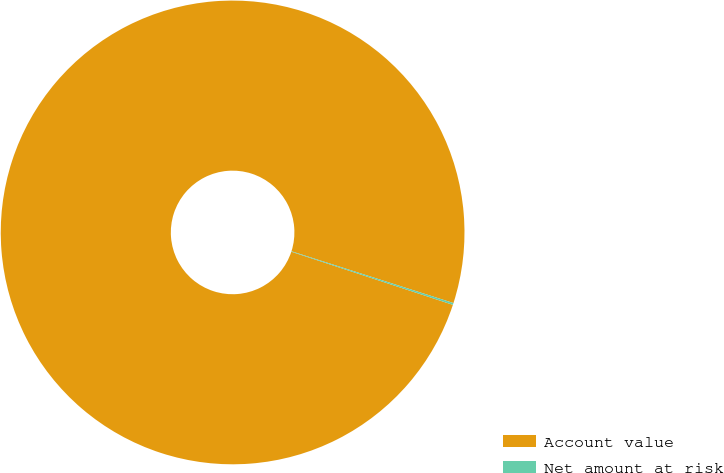Convert chart to OTSL. <chart><loc_0><loc_0><loc_500><loc_500><pie_chart><fcel>Account value<fcel>Net amount at risk<nl><fcel>99.87%<fcel>0.13%<nl></chart> 